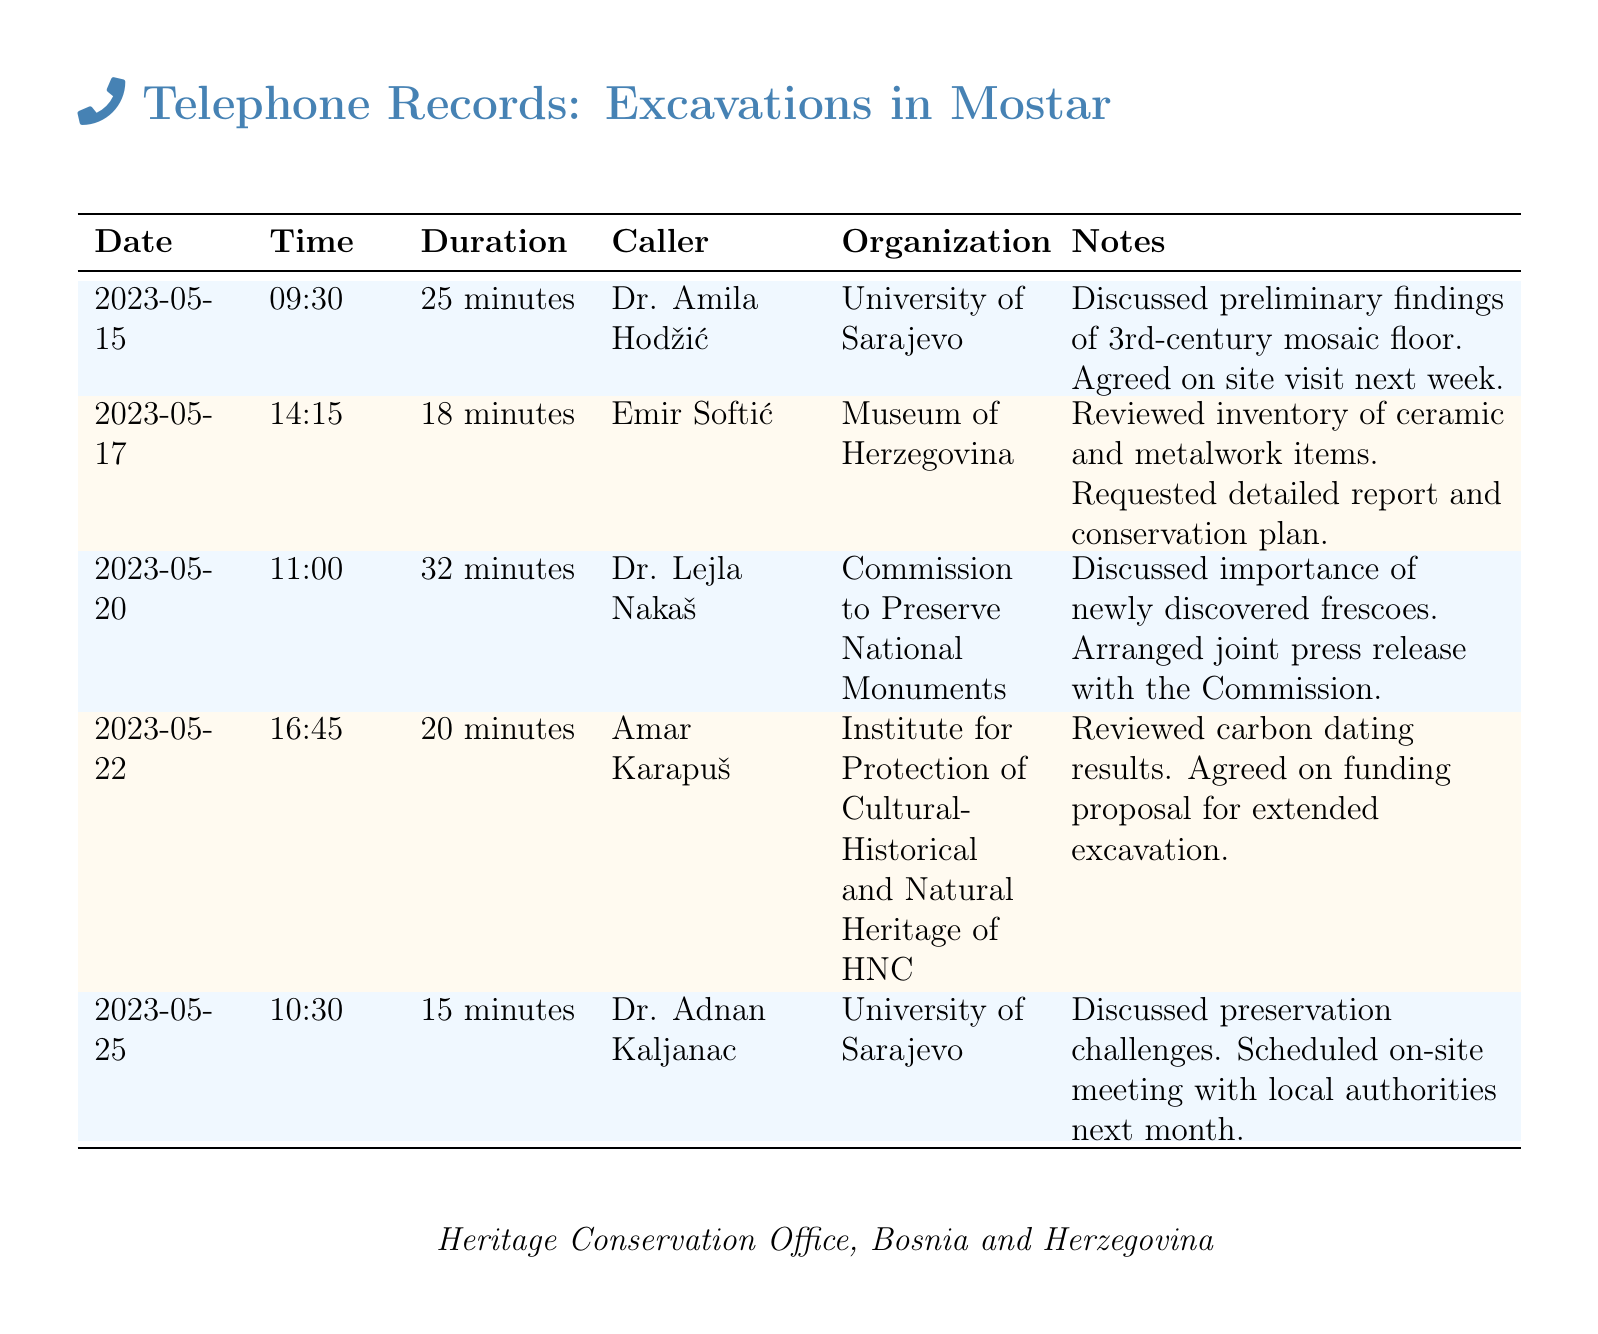what is the date of the first recorded consultation? The first recorded consultation took place on May 15, 2023.
Answer: May 15, 2023 who called on May 17, 2023? The caller on May 17, 2023, was Emir Softić.
Answer: Emir Softić how long was the consultation with Dr. Lejla Nakaš? The consultation with Dr. Lejla Nakaš lasted 32 minutes.
Answer: 32 minutes which organization is Dr. Adnan Kaljanac affiliated with? Dr. Adnan Kaljanac is affiliated with the University of Sarajevo.
Answer: University of Sarajevo what key topic was discussed on May 22, 2023? The key topic discussed was carbon dating results and funding proposals.
Answer: carbon dating results and funding proposals how many consultations were recorded in total? There were five consultations recorded in total.
Answer: five when is the scheduled on-site meeting with local authorities? The on-site meeting with local authorities is scheduled for next month.
Answer: next month what is the focus of the request made by Emir Softić during the consultation? Emir Softić requested a detailed report and conservation plan.
Answer: detailed report and conservation plan who agreed to arrange a joint press release? Dr. Lejla Nakaš agreed to arrange a joint press release with the Commission.
Answer: Dr. Lejla Nakaš 